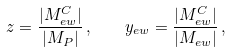<formula> <loc_0><loc_0><loc_500><loc_500>z = \frac { | M _ { e w } ^ { C } | } { | M _ { P } | } \, , \quad y _ { e w } = \frac { | M _ { e w } ^ { C } | } { | M _ { e w } | } \, ,</formula> 